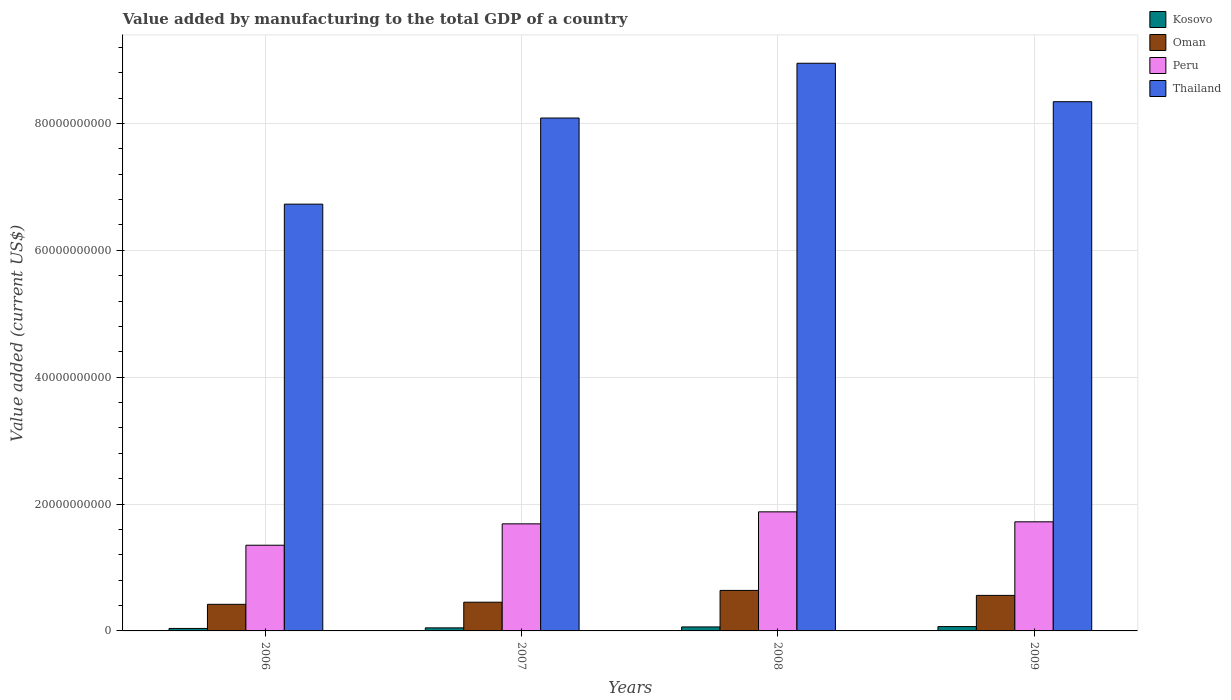How many different coloured bars are there?
Give a very brief answer. 4. How many groups of bars are there?
Provide a succinct answer. 4. Are the number of bars on each tick of the X-axis equal?
Your answer should be very brief. Yes. How many bars are there on the 2nd tick from the left?
Provide a succinct answer. 4. What is the value added by manufacturing to the total GDP in Oman in 2006?
Your answer should be compact. 4.19e+09. Across all years, what is the maximum value added by manufacturing to the total GDP in Thailand?
Offer a very short reply. 8.95e+1. Across all years, what is the minimum value added by manufacturing to the total GDP in Kosovo?
Provide a short and direct response. 3.90e+08. In which year was the value added by manufacturing to the total GDP in Kosovo minimum?
Offer a terse response. 2006. What is the total value added by manufacturing to the total GDP in Kosovo in the graph?
Ensure brevity in your answer.  2.18e+09. What is the difference between the value added by manufacturing to the total GDP in Kosovo in 2006 and that in 2007?
Give a very brief answer. -9.16e+07. What is the difference between the value added by manufacturing to the total GDP in Thailand in 2007 and the value added by manufacturing to the total GDP in Peru in 2008?
Make the answer very short. 6.21e+1. What is the average value added by manufacturing to the total GDP in Peru per year?
Provide a short and direct response. 1.66e+1. In the year 2009, what is the difference between the value added by manufacturing to the total GDP in Peru and value added by manufacturing to the total GDP in Oman?
Offer a very short reply. 1.16e+1. What is the ratio of the value added by manufacturing to the total GDP in Kosovo in 2006 to that in 2007?
Ensure brevity in your answer.  0.81. Is the value added by manufacturing to the total GDP in Peru in 2006 less than that in 2009?
Offer a very short reply. Yes. What is the difference between the highest and the second highest value added by manufacturing to the total GDP in Oman?
Give a very brief answer. 7.83e+08. What is the difference between the highest and the lowest value added by manufacturing to the total GDP in Thailand?
Keep it short and to the point. 2.22e+1. In how many years, is the value added by manufacturing to the total GDP in Thailand greater than the average value added by manufacturing to the total GDP in Thailand taken over all years?
Offer a terse response. 3. Is it the case that in every year, the sum of the value added by manufacturing to the total GDP in Thailand and value added by manufacturing to the total GDP in Kosovo is greater than the sum of value added by manufacturing to the total GDP in Peru and value added by manufacturing to the total GDP in Oman?
Give a very brief answer. Yes. What is the difference between two consecutive major ticks on the Y-axis?
Give a very brief answer. 2.00e+1. Are the values on the major ticks of Y-axis written in scientific E-notation?
Provide a short and direct response. No. Does the graph contain any zero values?
Your answer should be compact. No. Does the graph contain grids?
Provide a short and direct response. Yes. What is the title of the graph?
Provide a succinct answer. Value added by manufacturing to the total GDP of a country. Does "Malaysia" appear as one of the legend labels in the graph?
Provide a succinct answer. No. What is the label or title of the X-axis?
Keep it short and to the point. Years. What is the label or title of the Y-axis?
Your answer should be very brief. Value added (current US$). What is the Value added (current US$) in Kosovo in 2006?
Your answer should be very brief. 3.90e+08. What is the Value added (current US$) in Oman in 2006?
Make the answer very short. 4.19e+09. What is the Value added (current US$) in Peru in 2006?
Offer a very short reply. 1.35e+1. What is the Value added (current US$) in Thailand in 2006?
Provide a short and direct response. 6.73e+1. What is the Value added (current US$) in Kosovo in 2007?
Ensure brevity in your answer.  4.82e+08. What is the Value added (current US$) of Oman in 2007?
Ensure brevity in your answer.  4.53e+09. What is the Value added (current US$) in Peru in 2007?
Your answer should be compact. 1.69e+1. What is the Value added (current US$) in Thailand in 2007?
Your answer should be compact. 8.08e+1. What is the Value added (current US$) in Kosovo in 2008?
Your answer should be compact. 6.29e+08. What is the Value added (current US$) in Oman in 2008?
Your response must be concise. 6.39e+09. What is the Value added (current US$) of Peru in 2008?
Ensure brevity in your answer.  1.88e+1. What is the Value added (current US$) in Thailand in 2008?
Offer a very short reply. 8.95e+1. What is the Value added (current US$) in Kosovo in 2009?
Provide a succinct answer. 6.82e+08. What is the Value added (current US$) of Oman in 2009?
Your response must be concise. 5.60e+09. What is the Value added (current US$) in Peru in 2009?
Offer a very short reply. 1.72e+1. What is the Value added (current US$) of Thailand in 2009?
Make the answer very short. 8.34e+1. Across all years, what is the maximum Value added (current US$) in Kosovo?
Keep it short and to the point. 6.82e+08. Across all years, what is the maximum Value added (current US$) of Oman?
Give a very brief answer. 6.39e+09. Across all years, what is the maximum Value added (current US$) of Peru?
Your answer should be very brief. 1.88e+1. Across all years, what is the maximum Value added (current US$) in Thailand?
Ensure brevity in your answer.  8.95e+1. Across all years, what is the minimum Value added (current US$) of Kosovo?
Make the answer very short. 3.90e+08. Across all years, what is the minimum Value added (current US$) in Oman?
Keep it short and to the point. 4.19e+09. Across all years, what is the minimum Value added (current US$) in Peru?
Offer a very short reply. 1.35e+1. Across all years, what is the minimum Value added (current US$) in Thailand?
Provide a short and direct response. 6.73e+1. What is the total Value added (current US$) in Kosovo in the graph?
Provide a short and direct response. 2.18e+09. What is the total Value added (current US$) of Oman in the graph?
Your response must be concise. 2.07e+1. What is the total Value added (current US$) in Peru in the graph?
Your response must be concise. 6.64e+1. What is the total Value added (current US$) of Thailand in the graph?
Ensure brevity in your answer.  3.21e+11. What is the difference between the Value added (current US$) in Kosovo in 2006 and that in 2007?
Ensure brevity in your answer.  -9.16e+07. What is the difference between the Value added (current US$) of Oman in 2006 and that in 2007?
Provide a succinct answer. -3.33e+08. What is the difference between the Value added (current US$) in Peru in 2006 and that in 2007?
Provide a succinct answer. -3.37e+09. What is the difference between the Value added (current US$) in Thailand in 2006 and that in 2007?
Provide a succinct answer. -1.36e+1. What is the difference between the Value added (current US$) of Kosovo in 2006 and that in 2008?
Make the answer very short. -2.39e+08. What is the difference between the Value added (current US$) of Oman in 2006 and that in 2008?
Your response must be concise. -2.19e+09. What is the difference between the Value added (current US$) in Peru in 2006 and that in 2008?
Provide a short and direct response. -5.26e+09. What is the difference between the Value added (current US$) in Thailand in 2006 and that in 2008?
Your answer should be compact. -2.22e+1. What is the difference between the Value added (current US$) of Kosovo in 2006 and that in 2009?
Your answer should be compact. -2.92e+08. What is the difference between the Value added (current US$) of Oman in 2006 and that in 2009?
Your answer should be compact. -1.41e+09. What is the difference between the Value added (current US$) of Peru in 2006 and that in 2009?
Provide a short and direct response. -3.69e+09. What is the difference between the Value added (current US$) of Thailand in 2006 and that in 2009?
Ensure brevity in your answer.  -1.61e+1. What is the difference between the Value added (current US$) in Kosovo in 2007 and that in 2008?
Provide a short and direct response. -1.47e+08. What is the difference between the Value added (current US$) in Oman in 2007 and that in 2008?
Ensure brevity in your answer.  -1.86e+09. What is the difference between the Value added (current US$) in Peru in 2007 and that in 2008?
Your answer should be compact. -1.89e+09. What is the difference between the Value added (current US$) of Thailand in 2007 and that in 2008?
Your answer should be compact. -8.63e+09. What is the difference between the Value added (current US$) in Kosovo in 2007 and that in 2009?
Make the answer very short. -2.01e+08. What is the difference between the Value added (current US$) of Oman in 2007 and that in 2009?
Ensure brevity in your answer.  -1.08e+09. What is the difference between the Value added (current US$) in Peru in 2007 and that in 2009?
Make the answer very short. -3.21e+08. What is the difference between the Value added (current US$) in Thailand in 2007 and that in 2009?
Provide a succinct answer. -2.57e+09. What is the difference between the Value added (current US$) of Kosovo in 2008 and that in 2009?
Your response must be concise. -5.33e+07. What is the difference between the Value added (current US$) in Oman in 2008 and that in 2009?
Make the answer very short. 7.83e+08. What is the difference between the Value added (current US$) in Peru in 2008 and that in 2009?
Your response must be concise. 1.57e+09. What is the difference between the Value added (current US$) in Thailand in 2008 and that in 2009?
Your answer should be very brief. 6.06e+09. What is the difference between the Value added (current US$) in Kosovo in 2006 and the Value added (current US$) in Oman in 2007?
Give a very brief answer. -4.14e+09. What is the difference between the Value added (current US$) in Kosovo in 2006 and the Value added (current US$) in Peru in 2007?
Keep it short and to the point. -1.65e+1. What is the difference between the Value added (current US$) in Kosovo in 2006 and the Value added (current US$) in Thailand in 2007?
Offer a terse response. -8.05e+1. What is the difference between the Value added (current US$) of Oman in 2006 and the Value added (current US$) of Peru in 2007?
Your answer should be compact. -1.27e+1. What is the difference between the Value added (current US$) in Oman in 2006 and the Value added (current US$) in Thailand in 2007?
Provide a short and direct response. -7.67e+1. What is the difference between the Value added (current US$) in Peru in 2006 and the Value added (current US$) in Thailand in 2007?
Give a very brief answer. -6.73e+1. What is the difference between the Value added (current US$) of Kosovo in 2006 and the Value added (current US$) of Oman in 2008?
Make the answer very short. -6.00e+09. What is the difference between the Value added (current US$) of Kosovo in 2006 and the Value added (current US$) of Peru in 2008?
Give a very brief answer. -1.84e+1. What is the difference between the Value added (current US$) of Kosovo in 2006 and the Value added (current US$) of Thailand in 2008?
Your answer should be compact. -8.91e+1. What is the difference between the Value added (current US$) of Oman in 2006 and the Value added (current US$) of Peru in 2008?
Give a very brief answer. -1.46e+1. What is the difference between the Value added (current US$) of Oman in 2006 and the Value added (current US$) of Thailand in 2008?
Provide a short and direct response. -8.53e+1. What is the difference between the Value added (current US$) of Peru in 2006 and the Value added (current US$) of Thailand in 2008?
Provide a succinct answer. -7.60e+1. What is the difference between the Value added (current US$) of Kosovo in 2006 and the Value added (current US$) of Oman in 2009?
Your response must be concise. -5.21e+09. What is the difference between the Value added (current US$) in Kosovo in 2006 and the Value added (current US$) in Peru in 2009?
Offer a very short reply. -1.68e+1. What is the difference between the Value added (current US$) in Kosovo in 2006 and the Value added (current US$) in Thailand in 2009?
Ensure brevity in your answer.  -8.30e+1. What is the difference between the Value added (current US$) in Oman in 2006 and the Value added (current US$) in Peru in 2009?
Provide a short and direct response. -1.30e+1. What is the difference between the Value added (current US$) of Oman in 2006 and the Value added (current US$) of Thailand in 2009?
Your answer should be very brief. -7.92e+1. What is the difference between the Value added (current US$) in Peru in 2006 and the Value added (current US$) in Thailand in 2009?
Make the answer very short. -6.99e+1. What is the difference between the Value added (current US$) in Kosovo in 2007 and the Value added (current US$) in Oman in 2008?
Provide a succinct answer. -5.90e+09. What is the difference between the Value added (current US$) in Kosovo in 2007 and the Value added (current US$) in Peru in 2008?
Your response must be concise. -1.83e+1. What is the difference between the Value added (current US$) in Kosovo in 2007 and the Value added (current US$) in Thailand in 2008?
Provide a short and direct response. -8.90e+1. What is the difference between the Value added (current US$) of Oman in 2007 and the Value added (current US$) of Peru in 2008?
Your answer should be very brief. -1.42e+1. What is the difference between the Value added (current US$) of Oman in 2007 and the Value added (current US$) of Thailand in 2008?
Provide a short and direct response. -8.50e+1. What is the difference between the Value added (current US$) in Peru in 2007 and the Value added (current US$) in Thailand in 2008?
Offer a terse response. -7.26e+1. What is the difference between the Value added (current US$) of Kosovo in 2007 and the Value added (current US$) of Oman in 2009?
Your response must be concise. -5.12e+09. What is the difference between the Value added (current US$) in Kosovo in 2007 and the Value added (current US$) in Peru in 2009?
Make the answer very short. -1.67e+1. What is the difference between the Value added (current US$) of Kosovo in 2007 and the Value added (current US$) of Thailand in 2009?
Ensure brevity in your answer.  -8.29e+1. What is the difference between the Value added (current US$) in Oman in 2007 and the Value added (current US$) in Peru in 2009?
Offer a terse response. -1.27e+1. What is the difference between the Value added (current US$) of Oman in 2007 and the Value added (current US$) of Thailand in 2009?
Your answer should be very brief. -7.89e+1. What is the difference between the Value added (current US$) of Peru in 2007 and the Value added (current US$) of Thailand in 2009?
Offer a terse response. -6.65e+1. What is the difference between the Value added (current US$) of Kosovo in 2008 and the Value added (current US$) of Oman in 2009?
Provide a short and direct response. -4.97e+09. What is the difference between the Value added (current US$) in Kosovo in 2008 and the Value added (current US$) in Peru in 2009?
Ensure brevity in your answer.  -1.66e+1. What is the difference between the Value added (current US$) of Kosovo in 2008 and the Value added (current US$) of Thailand in 2009?
Provide a short and direct response. -8.28e+1. What is the difference between the Value added (current US$) of Oman in 2008 and the Value added (current US$) of Peru in 2009?
Ensure brevity in your answer.  -1.08e+1. What is the difference between the Value added (current US$) in Oman in 2008 and the Value added (current US$) in Thailand in 2009?
Give a very brief answer. -7.70e+1. What is the difference between the Value added (current US$) in Peru in 2008 and the Value added (current US$) in Thailand in 2009?
Ensure brevity in your answer.  -6.47e+1. What is the average Value added (current US$) of Kosovo per year?
Provide a short and direct response. 5.46e+08. What is the average Value added (current US$) in Oman per year?
Ensure brevity in your answer.  5.18e+09. What is the average Value added (current US$) of Peru per year?
Offer a terse response. 1.66e+1. What is the average Value added (current US$) in Thailand per year?
Offer a very short reply. 8.03e+1. In the year 2006, what is the difference between the Value added (current US$) of Kosovo and Value added (current US$) of Oman?
Give a very brief answer. -3.80e+09. In the year 2006, what is the difference between the Value added (current US$) of Kosovo and Value added (current US$) of Peru?
Your answer should be very brief. -1.31e+1. In the year 2006, what is the difference between the Value added (current US$) in Kosovo and Value added (current US$) in Thailand?
Your answer should be compact. -6.69e+1. In the year 2006, what is the difference between the Value added (current US$) in Oman and Value added (current US$) in Peru?
Your response must be concise. -9.32e+09. In the year 2006, what is the difference between the Value added (current US$) in Oman and Value added (current US$) in Thailand?
Offer a terse response. -6.31e+1. In the year 2006, what is the difference between the Value added (current US$) in Peru and Value added (current US$) in Thailand?
Provide a succinct answer. -5.38e+1. In the year 2007, what is the difference between the Value added (current US$) in Kosovo and Value added (current US$) in Oman?
Your response must be concise. -4.04e+09. In the year 2007, what is the difference between the Value added (current US$) of Kosovo and Value added (current US$) of Peru?
Ensure brevity in your answer.  -1.64e+1. In the year 2007, what is the difference between the Value added (current US$) in Kosovo and Value added (current US$) in Thailand?
Provide a short and direct response. -8.04e+1. In the year 2007, what is the difference between the Value added (current US$) in Oman and Value added (current US$) in Peru?
Your response must be concise. -1.24e+1. In the year 2007, what is the difference between the Value added (current US$) in Oman and Value added (current US$) in Thailand?
Your answer should be compact. -7.63e+1. In the year 2007, what is the difference between the Value added (current US$) in Peru and Value added (current US$) in Thailand?
Your response must be concise. -6.40e+1. In the year 2008, what is the difference between the Value added (current US$) of Kosovo and Value added (current US$) of Oman?
Keep it short and to the point. -5.76e+09. In the year 2008, what is the difference between the Value added (current US$) of Kosovo and Value added (current US$) of Peru?
Offer a terse response. -1.81e+1. In the year 2008, what is the difference between the Value added (current US$) of Kosovo and Value added (current US$) of Thailand?
Ensure brevity in your answer.  -8.89e+1. In the year 2008, what is the difference between the Value added (current US$) in Oman and Value added (current US$) in Peru?
Your response must be concise. -1.24e+1. In the year 2008, what is the difference between the Value added (current US$) in Oman and Value added (current US$) in Thailand?
Offer a very short reply. -8.31e+1. In the year 2008, what is the difference between the Value added (current US$) in Peru and Value added (current US$) in Thailand?
Your answer should be very brief. -7.07e+1. In the year 2009, what is the difference between the Value added (current US$) in Kosovo and Value added (current US$) in Oman?
Keep it short and to the point. -4.92e+09. In the year 2009, what is the difference between the Value added (current US$) in Kosovo and Value added (current US$) in Peru?
Make the answer very short. -1.65e+1. In the year 2009, what is the difference between the Value added (current US$) of Kosovo and Value added (current US$) of Thailand?
Your answer should be very brief. -8.27e+1. In the year 2009, what is the difference between the Value added (current US$) of Oman and Value added (current US$) of Peru?
Your answer should be compact. -1.16e+1. In the year 2009, what is the difference between the Value added (current US$) of Oman and Value added (current US$) of Thailand?
Keep it short and to the point. -7.78e+1. In the year 2009, what is the difference between the Value added (current US$) of Peru and Value added (current US$) of Thailand?
Your answer should be very brief. -6.62e+1. What is the ratio of the Value added (current US$) in Kosovo in 2006 to that in 2007?
Provide a succinct answer. 0.81. What is the ratio of the Value added (current US$) in Oman in 2006 to that in 2007?
Offer a very short reply. 0.93. What is the ratio of the Value added (current US$) in Peru in 2006 to that in 2007?
Offer a very short reply. 0.8. What is the ratio of the Value added (current US$) in Thailand in 2006 to that in 2007?
Your answer should be compact. 0.83. What is the ratio of the Value added (current US$) of Kosovo in 2006 to that in 2008?
Your response must be concise. 0.62. What is the ratio of the Value added (current US$) of Oman in 2006 to that in 2008?
Your response must be concise. 0.66. What is the ratio of the Value added (current US$) of Peru in 2006 to that in 2008?
Your response must be concise. 0.72. What is the ratio of the Value added (current US$) in Thailand in 2006 to that in 2008?
Provide a short and direct response. 0.75. What is the ratio of the Value added (current US$) in Kosovo in 2006 to that in 2009?
Keep it short and to the point. 0.57. What is the ratio of the Value added (current US$) in Oman in 2006 to that in 2009?
Give a very brief answer. 0.75. What is the ratio of the Value added (current US$) in Peru in 2006 to that in 2009?
Your response must be concise. 0.79. What is the ratio of the Value added (current US$) in Thailand in 2006 to that in 2009?
Provide a succinct answer. 0.81. What is the ratio of the Value added (current US$) of Kosovo in 2007 to that in 2008?
Provide a short and direct response. 0.77. What is the ratio of the Value added (current US$) of Oman in 2007 to that in 2008?
Provide a succinct answer. 0.71. What is the ratio of the Value added (current US$) in Peru in 2007 to that in 2008?
Make the answer very short. 0.9. What is the ratio of the Value added (current US$) of Thailand in 2007 to that in 2008?
Make the answer very short. 0.9. What is the ratio of the Value added (current US$) in Kosovo in 2007 to that in 2009?
Your answer should be compact. 0.71. What is the ratio of the Value added (current US$) of Oman in 2007 to that in 2009?
Your response must be concise. 0.81. What is the ratio of the Value added (current US$) of Peru in 2007 to that in 2009?
Keep it short and to the point. 0.98. What is the ratio of the Value added (current US$) of Thailand in 2007 to that in 2009?
Keep it short and to the point. 0.97. What is the ratio of the Value added (current US$) of Kosovo in 2008 to that in 2009?
Offer a terse response. 0.92. What is the ratio of the Value added (current US$) in Oman in 2008 to that in 2009?
Offer a terse response. 1.14. What is the ratio of the Value added (current US$) of Peru in 2008 to that in 2009?
Your answer should be very brief. 1.09. What is the ratio of the Value added (current US$) of Thailand in 2008 to that in 2009?
Your answer should be very brief. 1.07. What is the difference between the highest and the second highest Value added (current US$) of Kosovo?
Make the answer very short. 5.33e+07. What is the difference between the highest and the second highest Value added (current US$) of Oman?
Provide a succinct answer. 7.83e+08. What is the difference between the highest and the second highest Value added (current US$) in Peru?
Ensure brevity in your answer.  1.57e+09. What is the difference between the highest and the second highest Value added (current US$) in Thailand?
Provide a succinct answer. 6.06e+09. What is the difference between the highest and the lowest Value added (current US$) of Kosovo?
Offer a very short reply. 2.92e+08. What is the difference between the highest and the lowest Value added (current US$) of Oman?
Your response must be concise. 2.19e+09. What is the difference between the highest and the lowest Value added (current US$) of Peru?
Provide a succinct answer. 5.26e+09. What is the difference between the highest and the lowest Value added (current US$) in Thailand?
Your answer should be compact. 2.22e+1. 